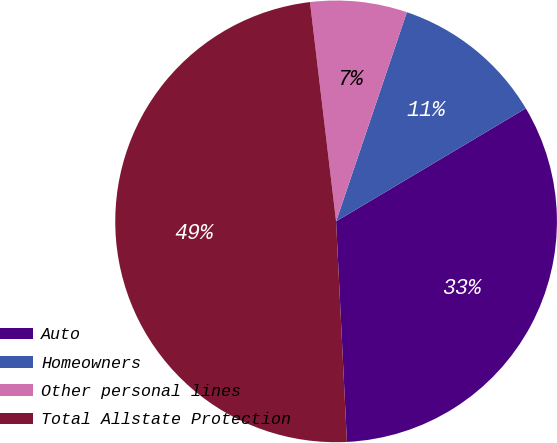<chart> <loc_0><loc_0><loc_500><loc_500><pie_chart><fcel>Auto<fcel>Homeowners<fcel>Other personal lines<fcel>Total Allstate Protection<nl><fcel>32.77%<fcel>11.26%<fcel>7.08%<fcel>48.9%<nl></chart> 